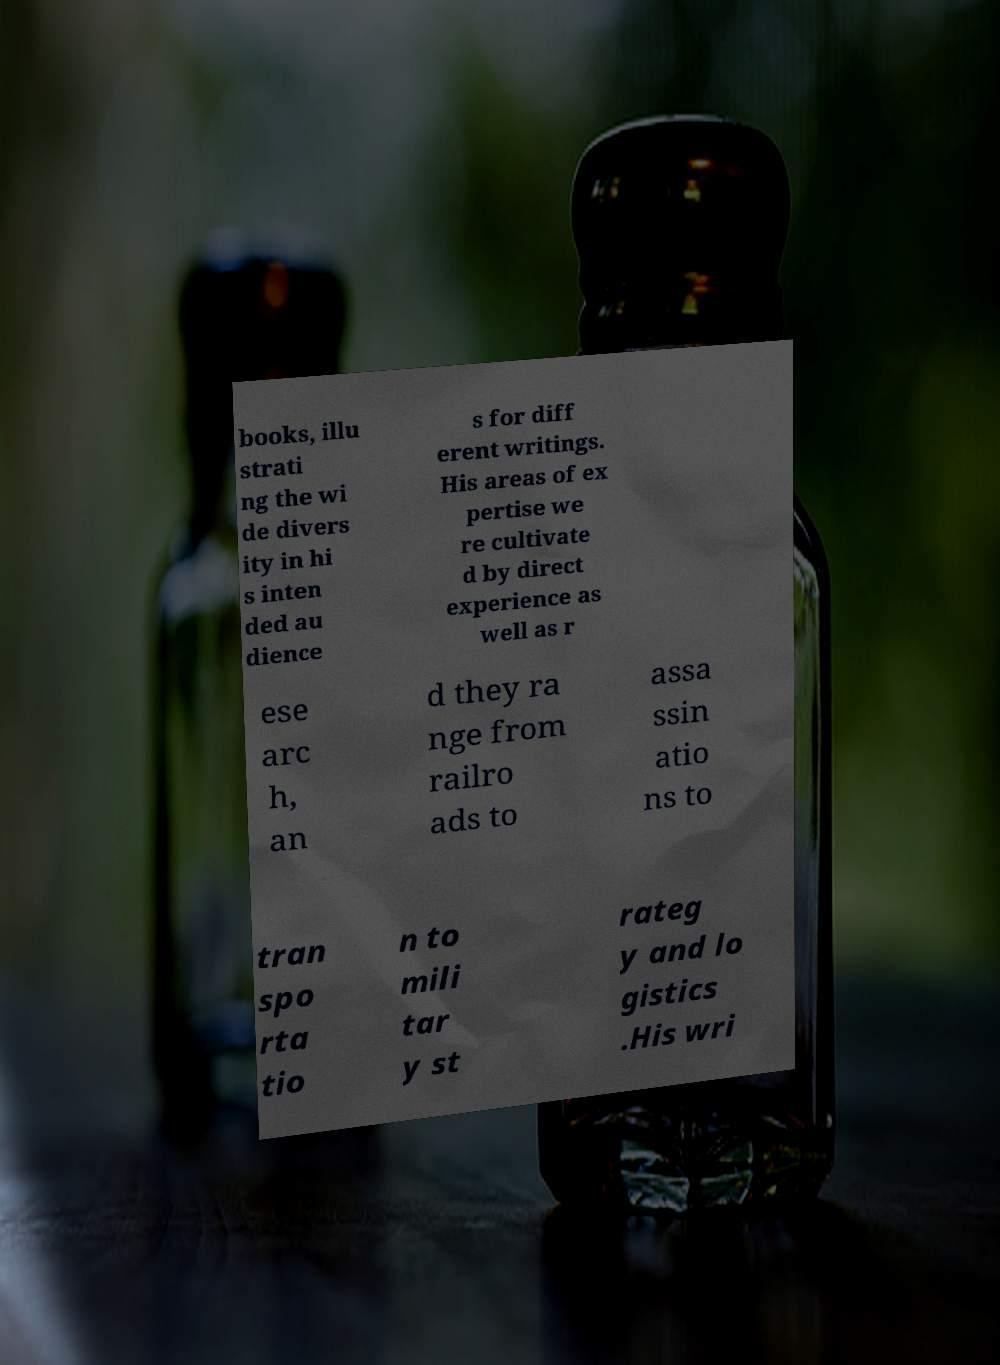For documentation purposes, I need the text within this image transcribed. Could you provide that? books, illu strati ng the wi de divers ity in hi s inten ded au dience s for diff erent writings. His areas of ex pertise we re cultivate d by direct experience as well as r ese arc h, an d they ra nge from railro ads to assa ssin atio ns to tran spo rta tio n to mili tar y st rateg y and lo gistics .His wri 